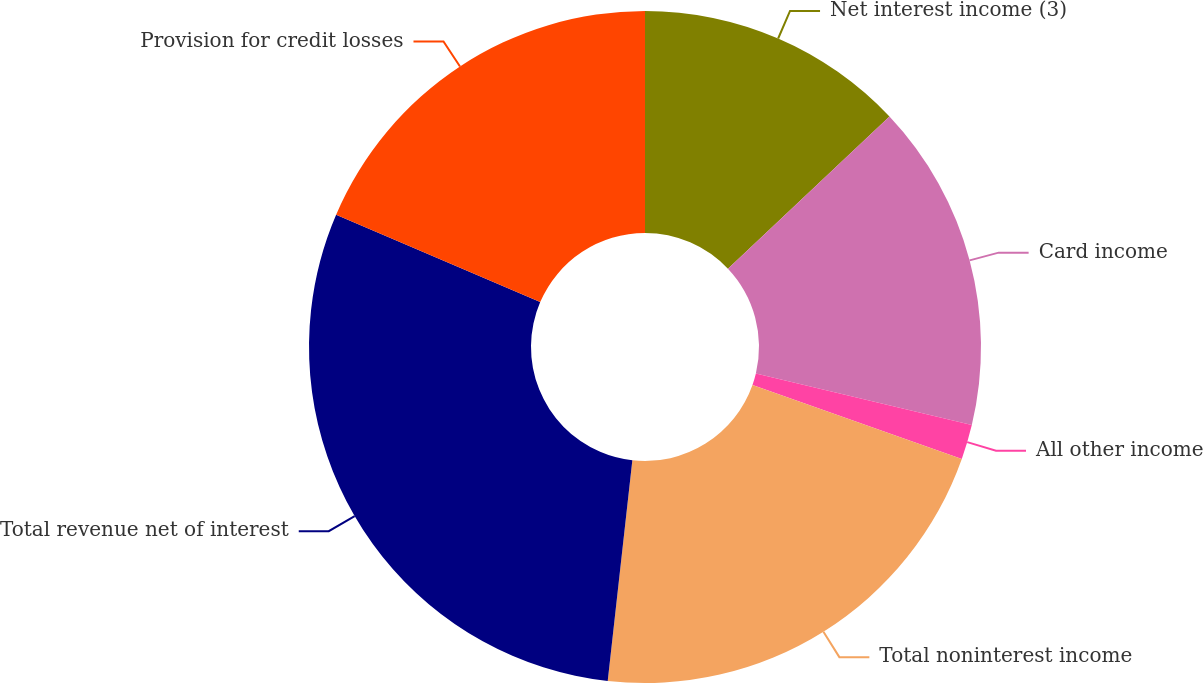Convert chart to OTSL. <chart><loc_0><loc_0><loc_500><loc_500><pie_chart><fcel>Net interest income (3)<fcel>Card income<fcel>All other income<fcel>Total noninterest income<fcel>Total revenue net of interest<fcel>Provision for credit losses<nl><fcel>12.97%<fcel>15.76%<fcel>1.68%<fcel>21.36%<fcel>29.67%<fcel>18.56%<nl></chart> 